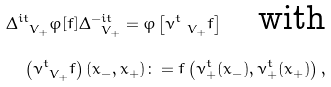Convert formula to latex. <formula><loc_0><loc_0><loc_500><loc_500>\Delta _ { \ V _ { + } } ^ { i t } \varphi [ f ] \Delta _ { \ V _ { + } } ^ { - i t } = \varphi \left [ \nu _ { \ V _ { + } } ^ { t } f \right ] \quad \text {with} \\ \left ( \nu _ { \ V _ { + } } ^ { t } f \right ) ( x _ { - } , x _ { + } ) \colon = f \left ( \nu _ { + } ^ { t } ( x _ { - } ) , \nu _ { + } ^ { t } ( x _ { + } ) \right ) ,</formula> 